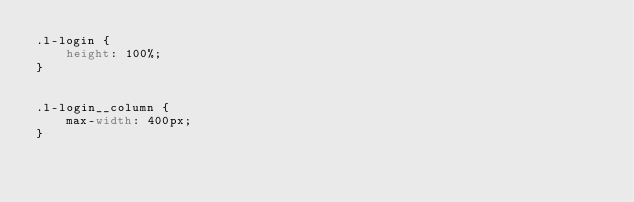Convert code to text. <code><loc_0><loc_0><loc_500><loc_500><_CSS_>.l-login {
    height: 100%;
}


.l-login__column {
    max-width: 400px;
}
</code> 